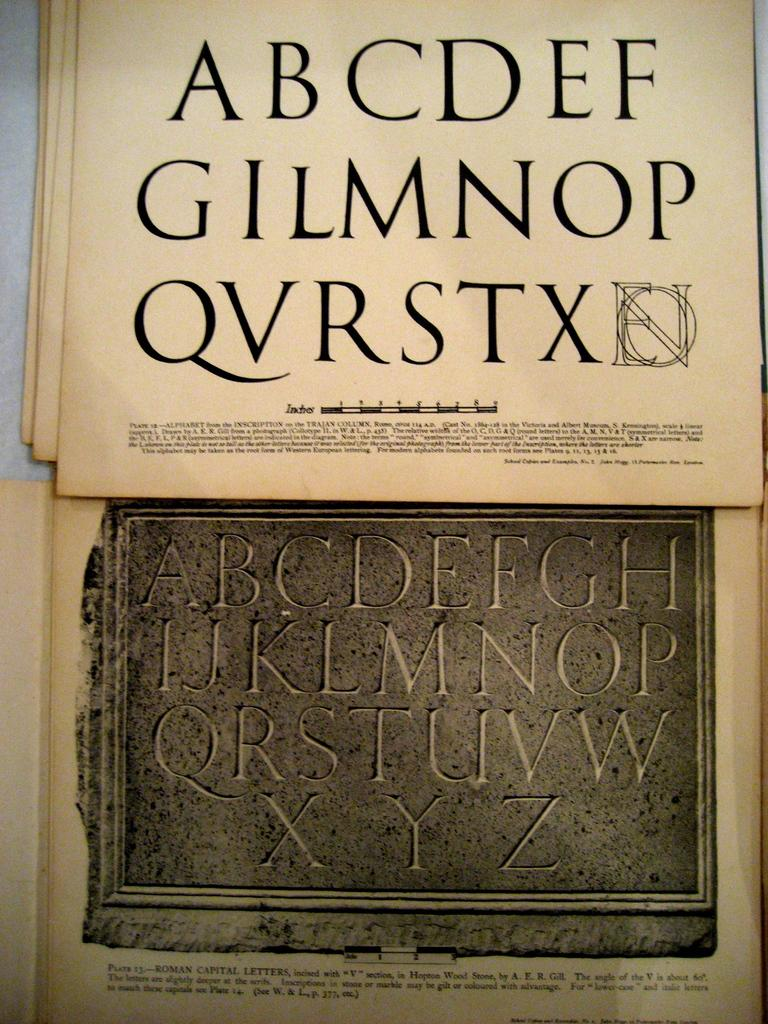<image>
Present a compact description of the photo's key features. A piece of paper which has ABCDEF written on the top. 